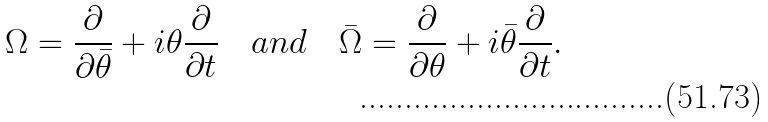<formula> <loc_0><loc_0><loc_500><loc_500>\Omega = \frac { \partial } { \partial \bar { \theta } } + i \theta \frac { \partial } { \partial t } \quad a n d \quad \bar { \Omega } = \frac { \partial } { \partial \theta } + i \bar { \theta } \frac { \partial } { \partial t } .</formula> 